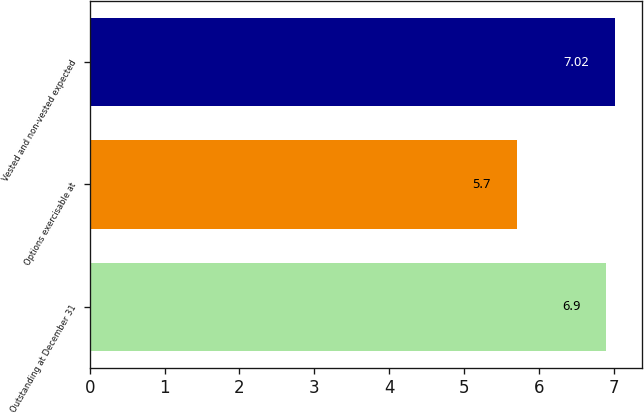Convert chart to OTSL. <chart><loc_0><loc_0><loc_500><loc_500><bar_chart><fcel>Outstanding at December 31<fcel>Options exercisable at<fcel>Vested and non-vested expected<nl><fcel>6.9<fcel>5.7<fcel>7.02<nl></chart> 